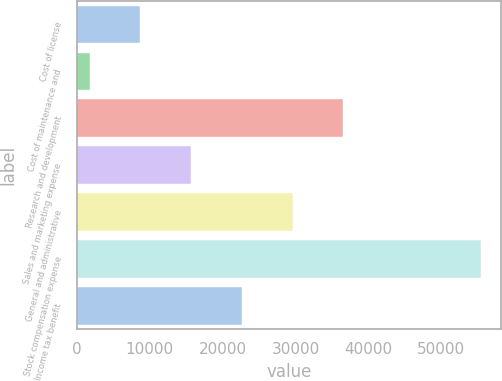Convert chart to OTSL. <chart><loc_0><loc_0><loc_500><loc_500><bar_chart><fcel>Cost of license<fcel>Cost of maintenance and<fcel>Research and development<fcel>Sales and marketing expense<fcel>General and administrative<fcel>Stock compensation expense<fcel>Income tax benefit<nl><fcel>8695.7<fcel>1727<fcel>36570.5<fcel>15664.4<fcel>29601.8<fcel>55425<fcel>22633.1<nl></chart> 